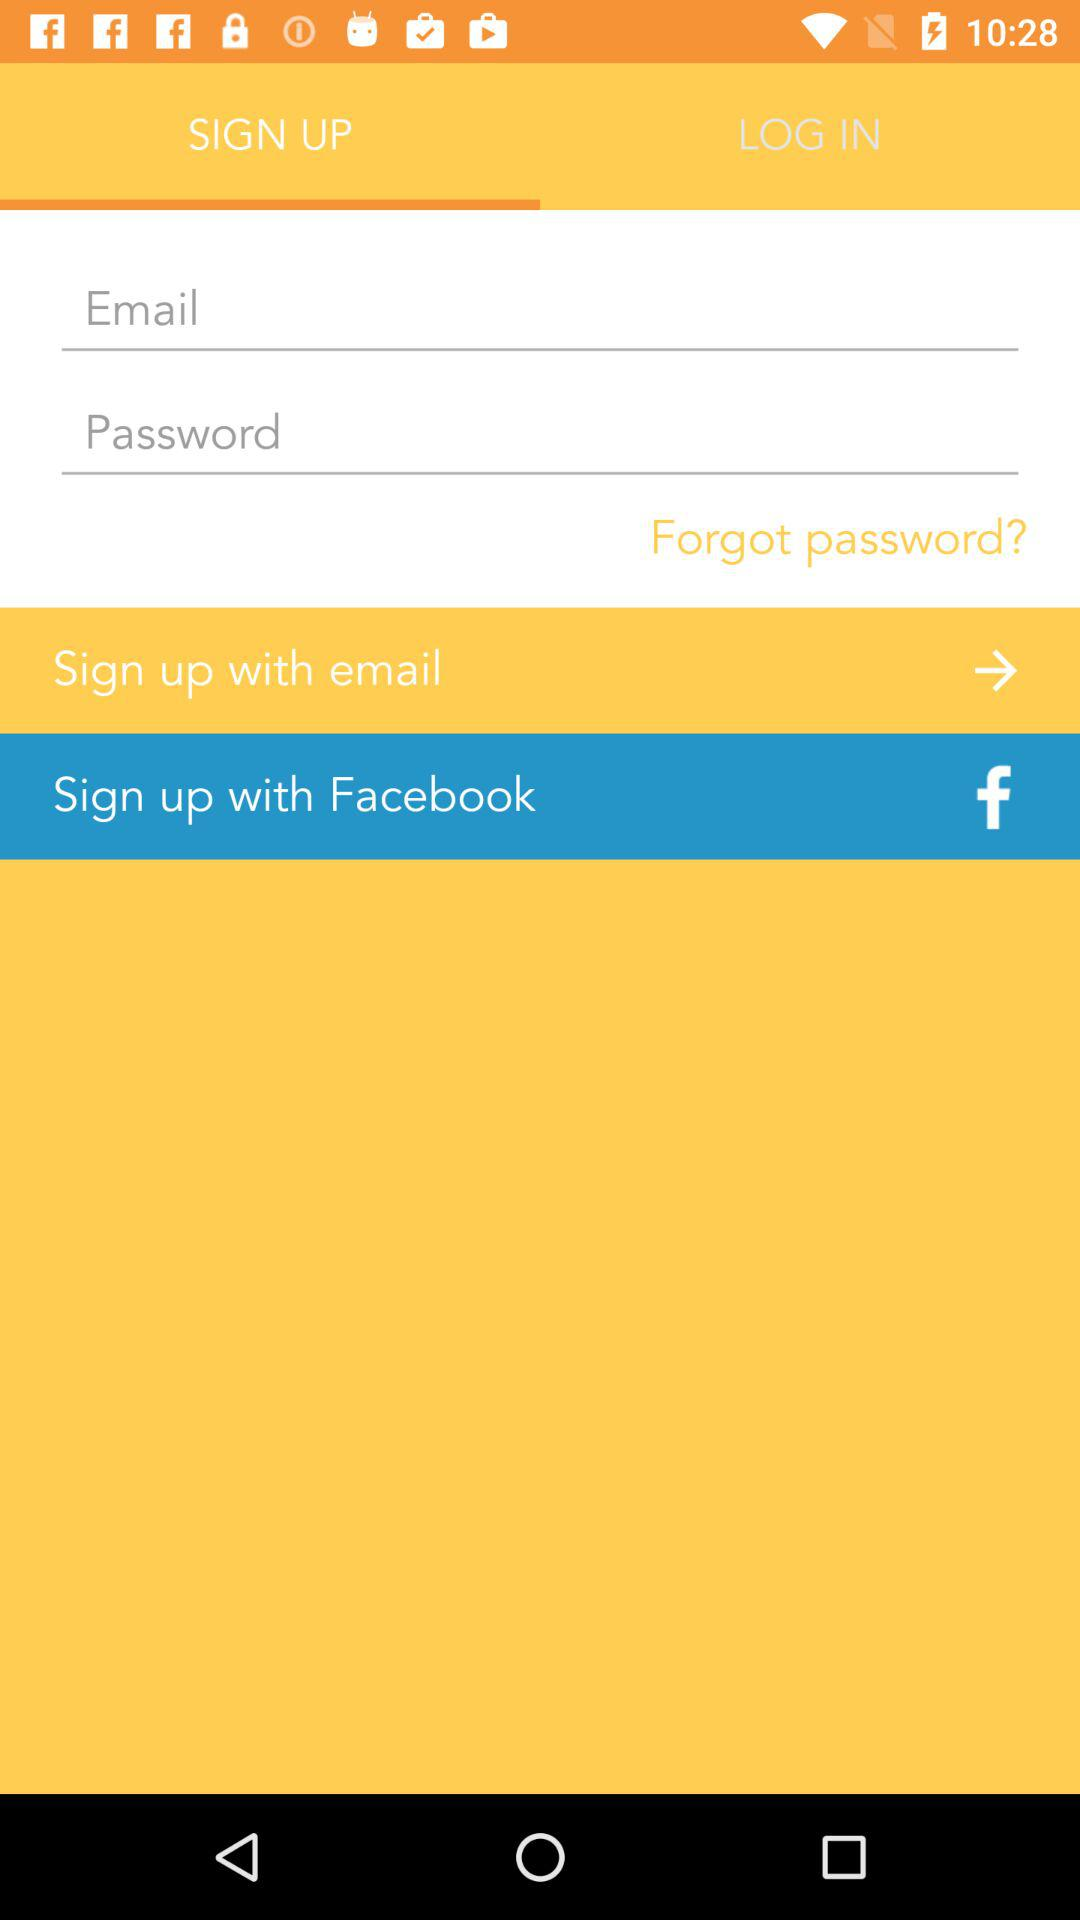Which tab is selected? The selected tab is "SIGN UP". 